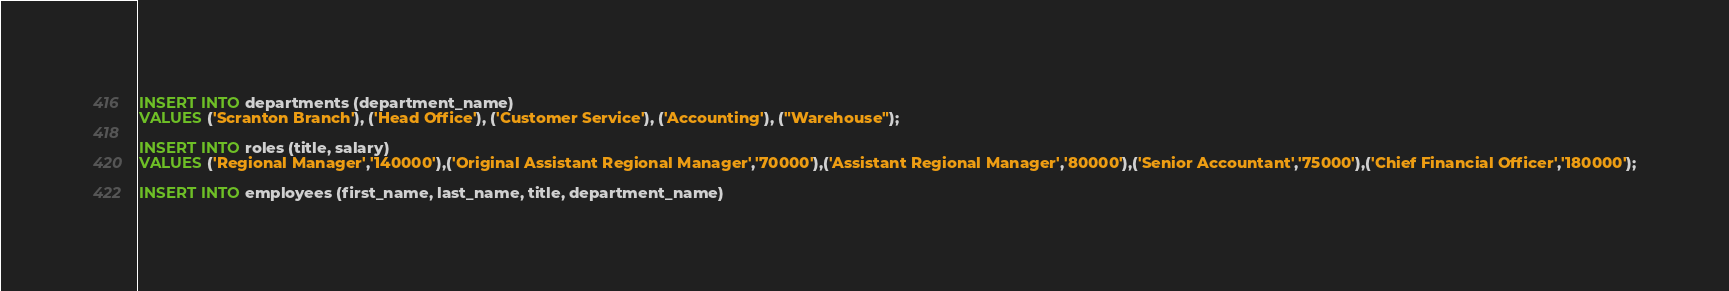Convert code to text. <code><loc_0><loc_0><loc_500><loc_500><_SQL_>INSERT INTO departments (department_name)
VALUES ('Scranton Branch'), ('Head Office'), ('Customer Service'), ('Accounting'), ("Warehouse");

INSERT INTO roles (title, salary)
VALUES ('Regional Manager','140000'),('Original Assistant Regional Manager','70000'),('Assistant Regional Manager','80000'),('Senior Accountant','75000'),('Chief Financial Officer','180000');

INSERT INTO employees (first_name, last_name, title, department_name)</code> 